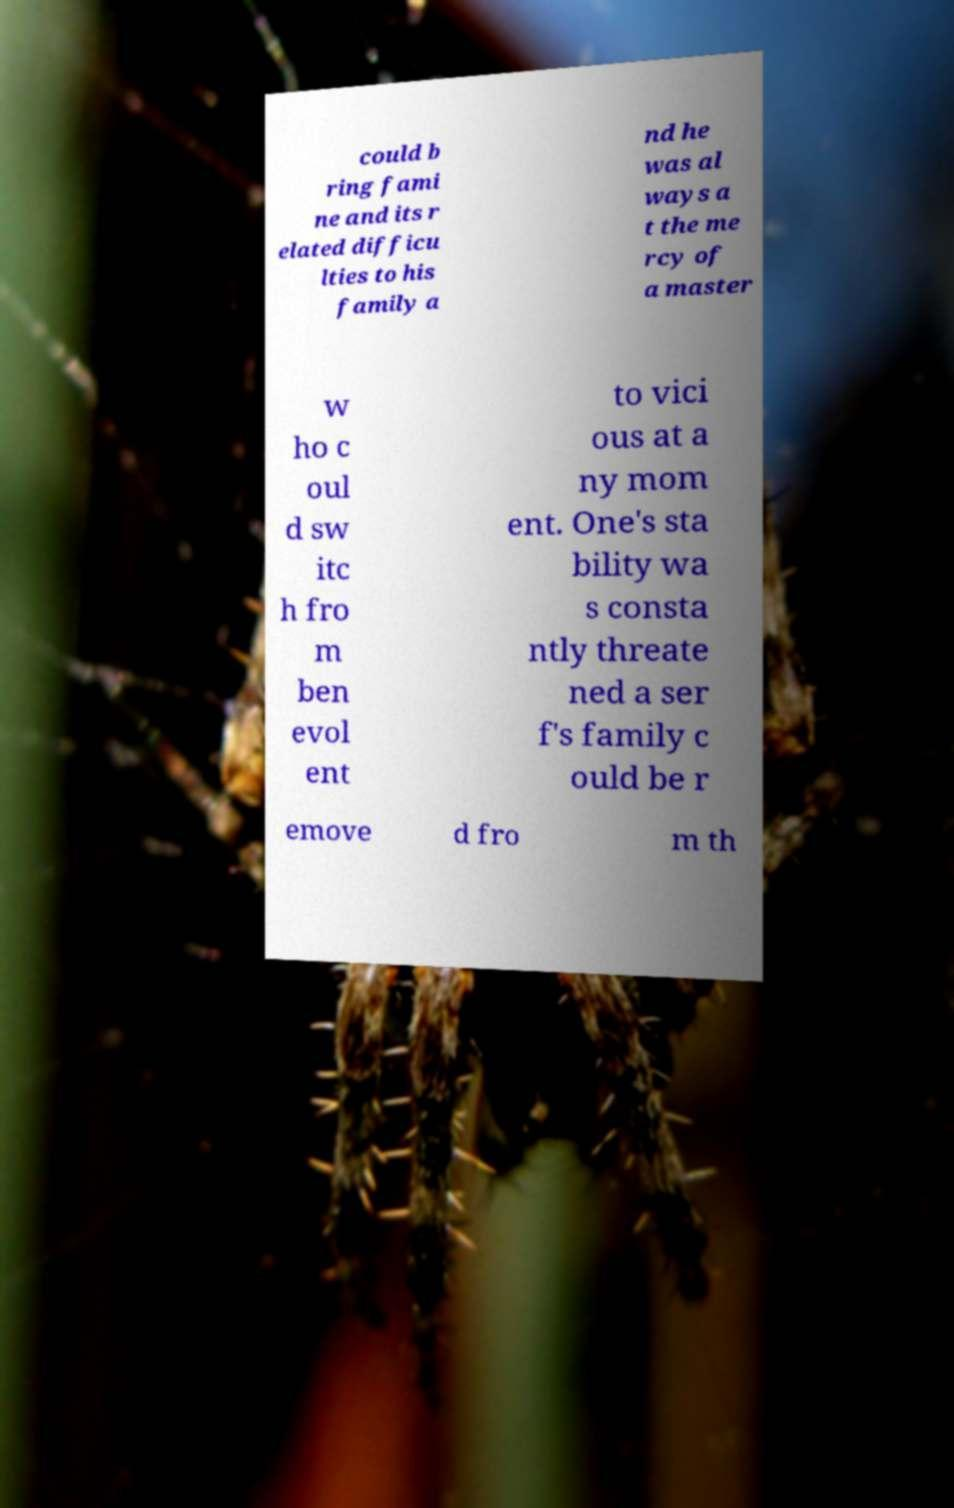Could you assist in decoding the text presented in this image and type it out clearly? could b ring fami ne and its r elated difficu lties to his family a nd he was al ways a t the me rcy of a master w ho c oul d sw itc h fro m ben evol ent to vici ous at a ny mom ent. One's sta bility wa s consta ntly threate ned a ser f's family c ould be r emove d fro m th 